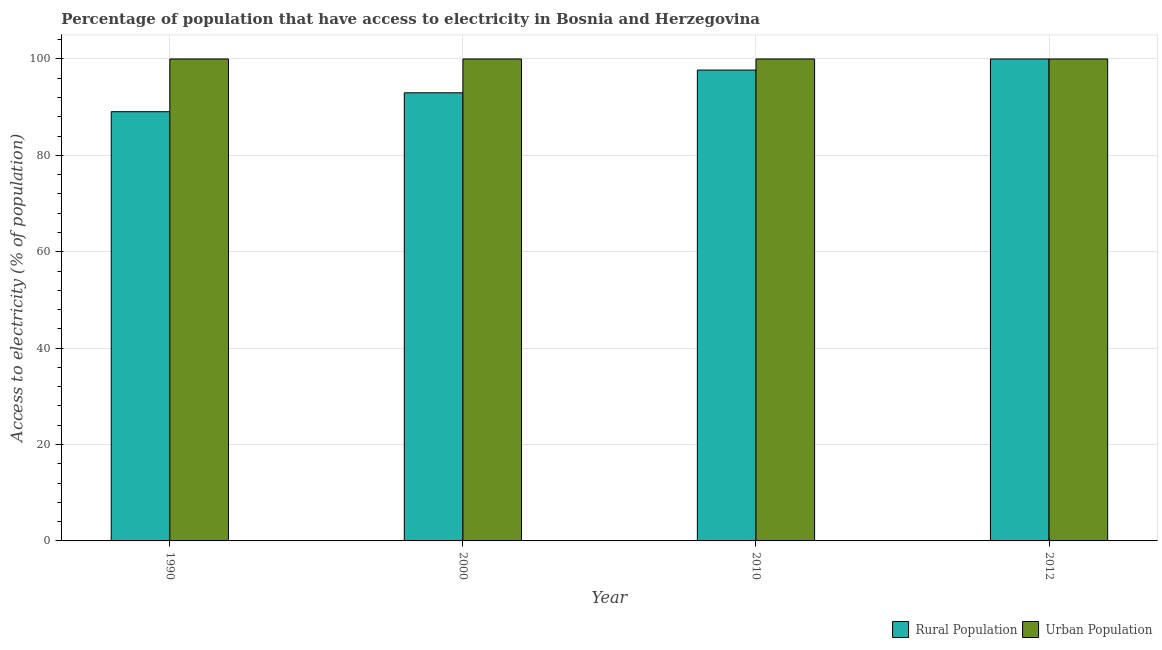How many groups of bars are there?
Your response must be concise. 4. Are the number of bars per tick equal to the number of legend labels?
Offer a very short reply. Yes. What is the percentage of rural population having access to electricity in 1990?
Ensure brevity in your answer.  89.06. Across all years, what is the maximum percentage of urban population having access to electricity?
Provide a succinct answer. 100. Across all years, what is the minimum percentage of rural population having access to electricity?
Ensure brevity in your answer.  89.06. In which year was the percentage of rural population having access to electricity minimum?
Ensure brevity in your answer.  1990. What is the total percentage of urban population having access to electricity in the graph?
Ensure brevity in your answer.  400. What is the difference between the percentage of urban population having access to electricity in 1990 and that in 2010?
Offer a very short reply. 0. What is the average percentage of rural population having access to electricity per year?
Provide a short and direct response. 94.94. In how many years, is the percentage of urban population having access to electricity greater than 32 %?
Keep it short and to the point. 4. Is the difference between the percentage of rural population having access to electricity in 2010 and 2012 greater than the difference between the percentage of urban population having access to electricity in 2010 and 2012?
Your answer should be very brief. No. What is the difference between the highest and the second highest percentage of urban population having access to electricity?
Ensure brevity in your answer.  0. What is the difference between the highest and the lowest percentage of rural population having access to electricity?
Provide a succinct answer. 10.94. In how many years, is the percentage of rural population having access to electricity greater than the average percentage of rural population having access to electricity taken over all years?
Provide a short and direct response. 2. Is the sum of the percentage of rural population having access to electricity in 2010 and 2012 greater than the maximum percentage of urban population having access to electricity across all years?
Give a very brief answer. Yes. What does the 2nd bar from the left in 2000 represents?
Your response must be concise. Urban Population. What does the 1st bar from the right in 1990 represents?
Offer a very short reply. Urban Population. How many bars are there?
Your answer should be compact. 8. Are the values on the major ticks of Y-axis written in scientific E-notation?
Ensure brevity in your answer.  No. Does the graph contain any zero values?
Give a very brief answer. No. Does the graph contain grids?
Give a very brief answer. Yes. How many legend labels are there?
Ensure brevity in your answer.  2. How are the legend labels stacked?
Give a very brief answer. Horizontal. What is the title of the graph?
Your answer should be very brief. Percentage of population that have access to electricity in Bosnia and Herzegovina. Does "Methane" appear as one of the legend labels in the graph?
Your response must be concise. No. What is the label or title of the X-axis?
Provide a succinct answer. Year. What is the label or title of the Y-axis?
Keep it short and to the point. Access to electricity (% of population). What is the Access to electricity (% of population) in Rural Population in 1990?
Make the answer very short. 89.06. What is the Access to electricity (% of population) of Rural Population in 2000?
Provide a succinct answer. 92.98. What is the Access to electricity (% of population) in Rural Population in 2010?
Offer a very short reply. 97.7. What is the Access to electricity (% of population) of Rural Population in 2012?
Offer a terse response. 100. Across all years, what is the maximum Access to electricity (% of population) of Rural Population?
Make the answer very short. 100. Across all years, what is the maximum Access to electricity (% of population) of Urban Population?
Make the answer very short. 100. Across all years, what is the minimum Access to electricity (% of population) of Rural Population?
Keep it short and to the point. 89.06. Across all years, what is the minimum Access to electricity (% of population) in Urban Population?
Offer a terse response. 100. What is the total Access to electricity (% of population) of Rural Population in the graph?
Offer a terse response. 379.74. What is the total Access to electricity (% of population) in Urban Population in the graph?
Provide a short and direct response. 400. What is the difference between the Access to electricity (% of population) in Rural Population in 1990 and that in 2000?
Offer a very short reply. -3.92. What is the difference between the Access to electricity (% of population) of Rural Population in 1990 and that in 2010?
Keep it short and to the point. -8.64. What is the difference between the Access to electricity (% of population) in Rural Population in 1990 and that in 2012?
Offer a terse response. -10.94. What is the difference between the Access to electricity (% of population) of Urban Population in 1990 and that in 2012?
Give a very brief answer. 0. What is the difference between the Access to electricity (% of population) of Rural Population in 2000 and that in 2010?
Ensure brevity in your answer.  -4.72. What is the difference between the Access to electricity (% of population) in Urban Population in 2000 and that in 2010?
Provide a short and direct response. 0. What is the difference between the Access to electricity (% of population) of Rural Population in 2000 and that in 2012?
Offer a very short reply. -7.02. What is the difference between the Access to electricity (% of population) in Urban Population in 2010 and that in 2012?
Offer a terse response. 0. What is the difference between the Access to electricity (% of population) in Rural Population in 1990 and the Access to electricity (% of population) in Urban Population in 2000?
Your answer should be compact. -10.94. What is the difference between the Access to electricity (% of population) of Rural Population in 1990 and the Access to electricity (% of population) of Urban Population in 2010?
Provide a short and direct response. -10.94. What is the difference between the Access to electricity (% of population) of Rural Population in 1990 and the Access to electricity (% of population) of Urban Population in 2012?
Offer a very short reply. -10.94. What is the difference between the Access to electricity (% of population) of Rural Population in 2000 and the Access to electricity (% of population) of Urban Population in 2010?
Provide a succinct answer. -7.02. What is the difference between the Access to electricity (% of population) in Rural Population in 2000 and the Access to electricity (% of population) in Urban Population in 2012?
Make the answer very short. -7.02. What is the difference between the Access to electricity (% of population) of Rural Population in 2010 and the Access to electricity (% of population) of Urban Population in 2012?
Keep it short and to the point. -2.3. What is the average Access to electricity (% of population) of Rural Population per year?
Ensure brevity in your answer.  94.94. What is the average Access to electricity (% of population) in Urban Population per year?
Keep it short and to the point. 100. In the year 1990, what is the difference between the Access to electricity (% of population) of Rural Population and Access to electricity (% of population) of Urban Population?
Your response must be concise. -10.94. In the year 2000, what is the difference between the Access to electricity (% of population) in Rural Population and Access to electricity (% of population) in Urban Population?
Give a very brief answer. -7.02. In the year 2012, what is the difference between the Access to electricity (% of population) of Rural Population and Access to electricity (% of population) of Urban Population?
Keep it short and to the point. 0. What is the ratio of the Access to electricity (% of population) of Rural Population in 1990 to that in 2000?
Give a very brief answer. 0.96. What is the ratio of the Access to electricity (% of population) of Rural Population in 1990 to that in 2010?
Your response must be concise. 0.91. What is the ratio of the Access to electricity (% of population) of Rural Population in 1990 to that in 2012?
Provide a succinct answer. 0.89. What is the ratio of the Access to electricity (% of population) of Urban Population in 1990 to that in 2012?
Give a very brief answer. 1. What is the ratio of the Access to electricity (% of population) in Rural Population in 2000 to that in 2010?
Your answer should be very brief. 0.95. What is the ratio of the Access to electricity (% of population) of Rural Population in 2000 to that in 2012?
Your answer should be compact. 0.93. What is the ratio of the Access to electricity (% of population) of Urban Population in 2000 to that in 2012?
Provide a short and direct response. 1. What is the difference between the highest and the second highest Access to electricity (% of population) in Rural Population?
Provide a succinct answer. 2.3. What is the difference between the highest and the second highest Access to electricity (% of population) of Urban Population?
Your response must be concise. 0. What is the difference between the highest and the lowest Access to electricity (% of population) of Rural Population?
Offer a very short reply. 10.94. What is the difference between the highest and the lowest Access to electricity (% of population) in Urban Population?
Give a very brief answer. 0. 